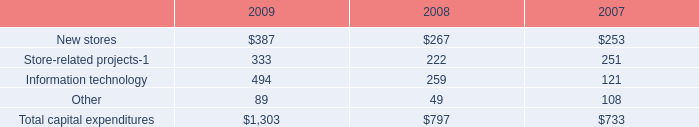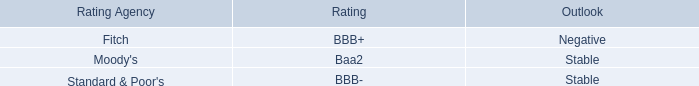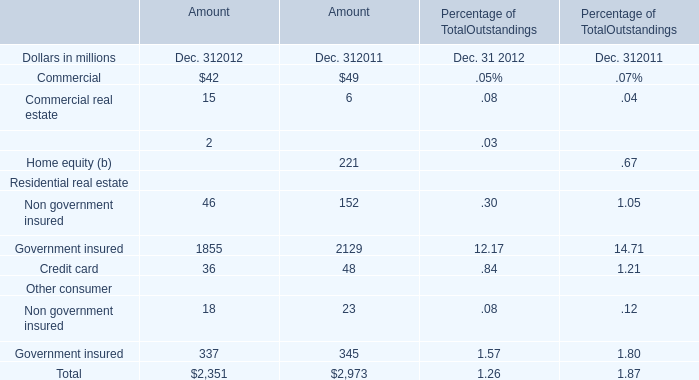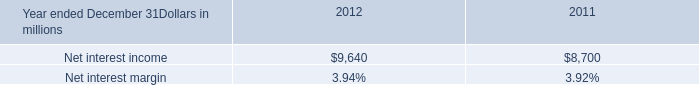what was the percentage change in the net interest income from 2011 to 2012 
Computations: ((9640 - 8700) / 8700)
Answer: 0.10805. 